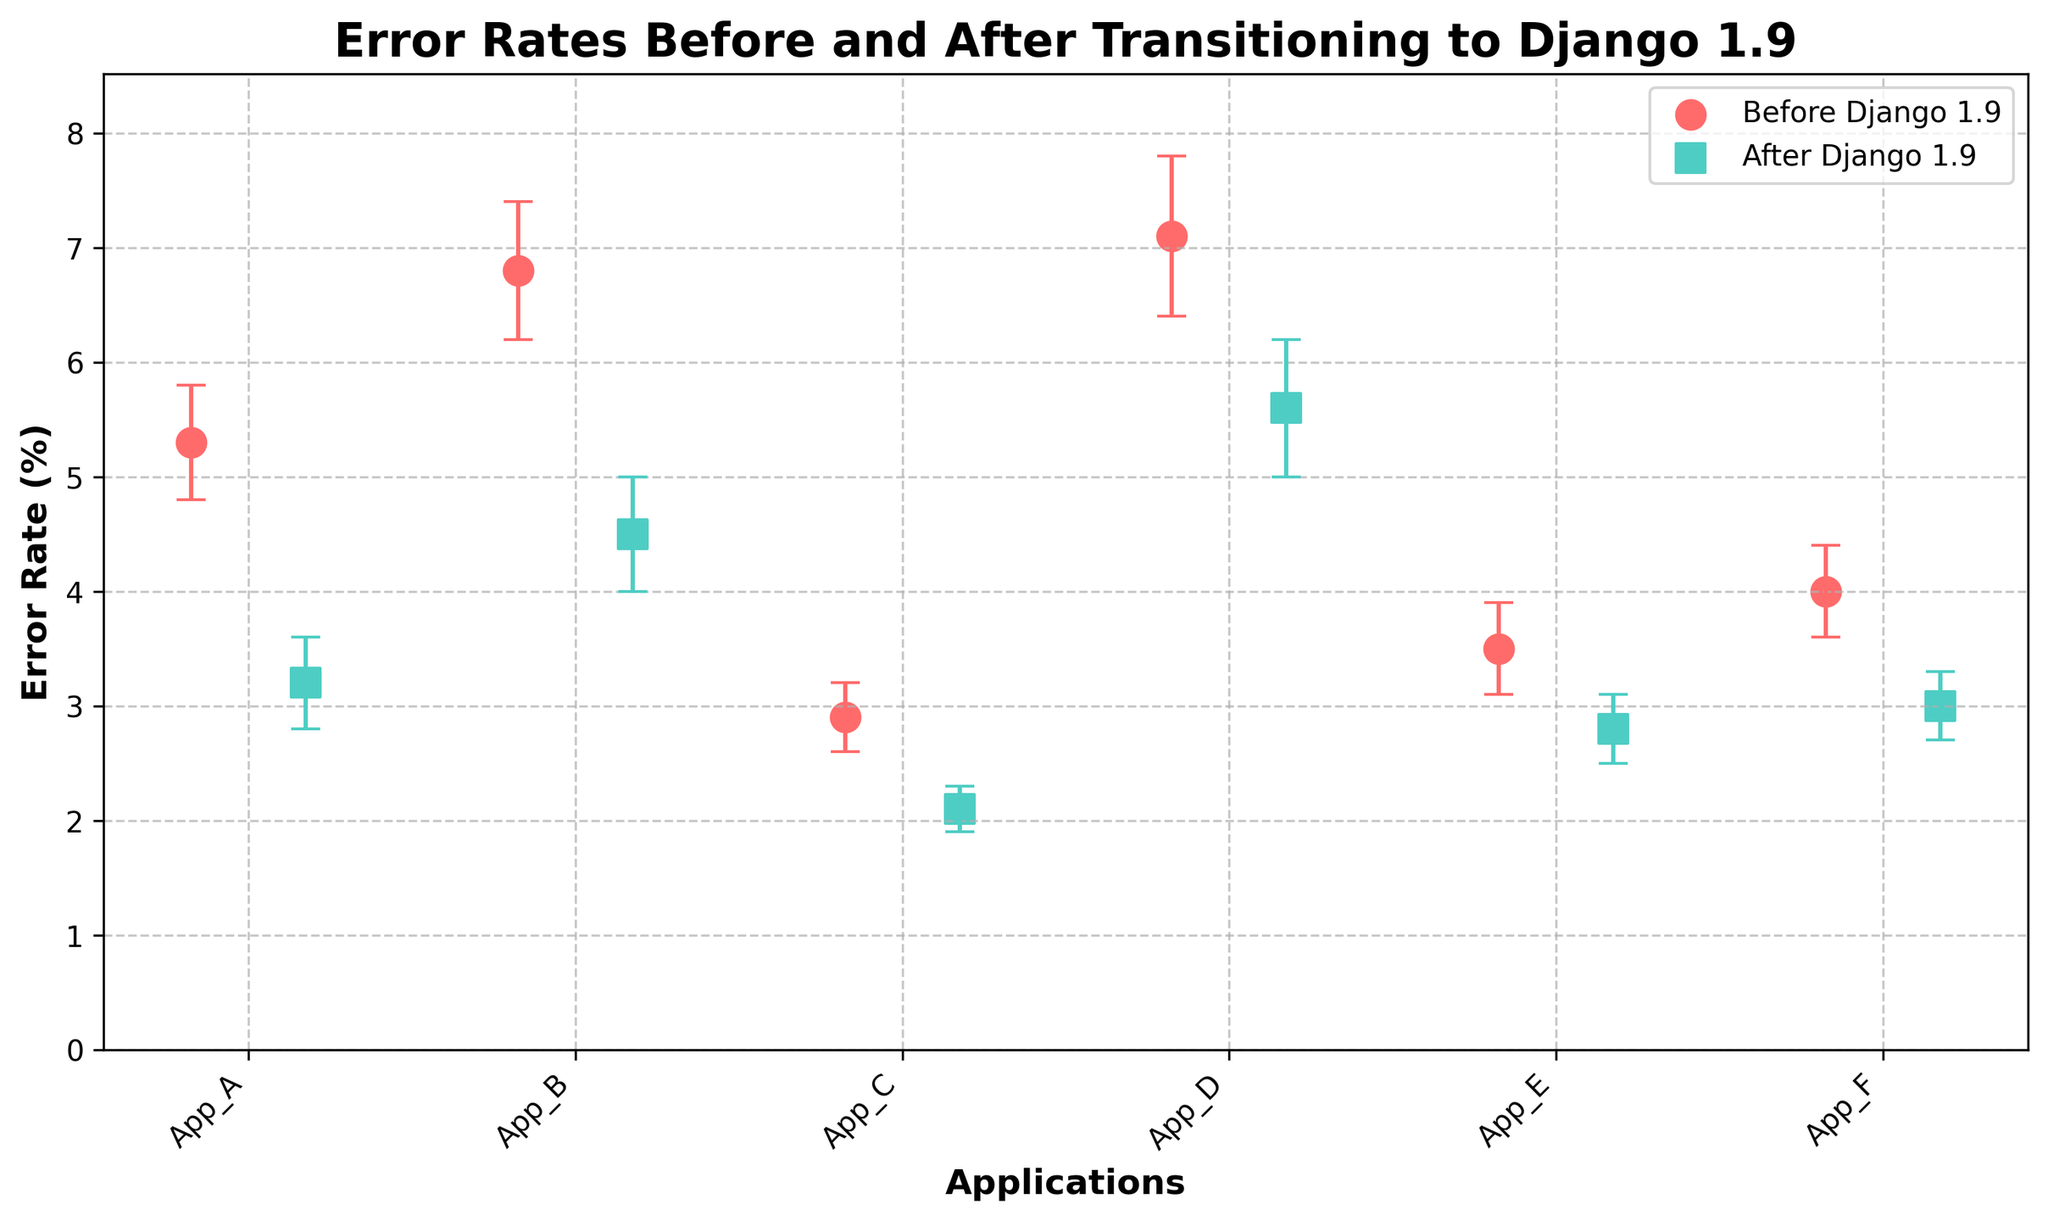What's the title of the figure? The title is usually found at the top of the figure and summarizes what the plot is about. In this case, the title is "Error Rates Before and After Transitioning to Django 1.9".
Answer: Error Rates Before and After Transitioning to Django 1.9 Which application had the highest error rate before transitioning to Django 1.9? You need to look at the scatter points representing "Before Django 1.9" and identify the one with the highest error rate. App_D has the highest value.
Answer: App_D Which application had the lowest error rate after transitioning to Django 1.9? You need to observe the scatter points marked "After Django 1.9" to find the one with the lowest error rate. App_C had the lowest error rate after transition.
Answer: App_C What is the difference in error rate for Application B before and after the transition? Subtract the 'after' error rate from the 'before' error rate for Application B. The error rates are 6.8 (before) and 4.5 (after), so the difference is 6.8 - 4.5.
Answer: 2.3 How many applications experienced a reduction in error rate after the transition to Django 1.9? Count all the applications where the error rate 'after' is less than the error rate 'before'. By observing the scatter points, all applications (App_A to App_F) show a visible reduction.
Answer: 6 What is the average error rate before the transition? Add all the error rates before the transition and divide by the number of applications. The error rates are 5.3, 6.8, 2.9, 7.1, 3.5, and 4.0. Summing these values and dividing by 6 gives the average. (5.3 + 6.8 + 2.9 + 7.1 + 3.5 + 4.0) / 6 = 4.93
Answer: 4.93 Which applications have overlapping error margins before and after the transition? Check if the error bars (margins) before and after overlap for each application. Apps like App_A and App_F show visible overlapping error margins.
Answer: App_A, App_F Visualize and interpret the overall trend in error rates before versus after the transition. Compare the two sets of scatter points as a whole. Error rates for all applications visibly decreased after transitioning to Django 1.9.
Answer: Decrease in error rates What is the range of error rates after transitioning for all applications? Find the minimum and maximum error rates after the transition and calculate the range. The error rates are from 2.1 to 5.6. Range is 5.6 - 2.1.
Answer: 3.5 